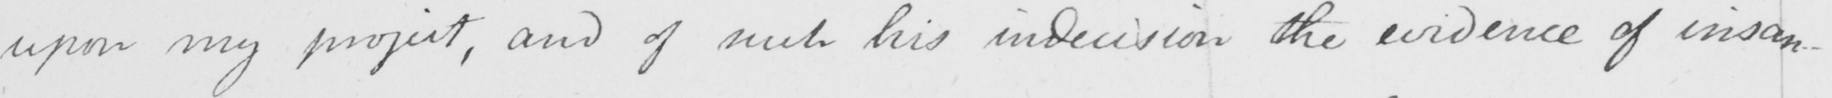Transcribe the text shown in this historical manuscript line. upon my project , and of such his indecision the evidence of insan- 